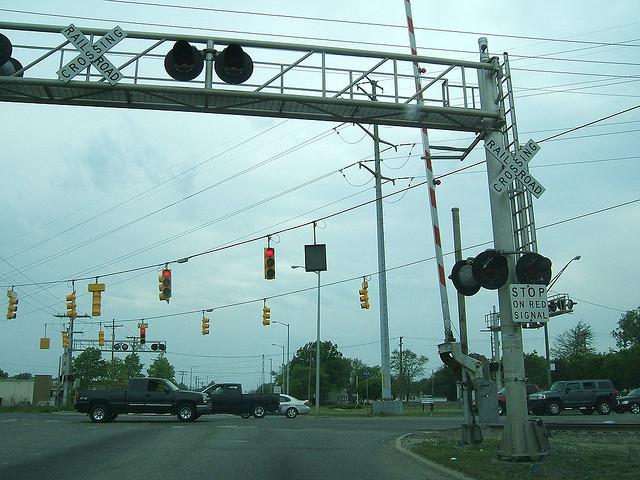What color are the traffic lights?
Be succinct. Red. What type of crossing is shown?
Be succinct. Railroad. What color is the truck?
Give a very brief answer. Black. 